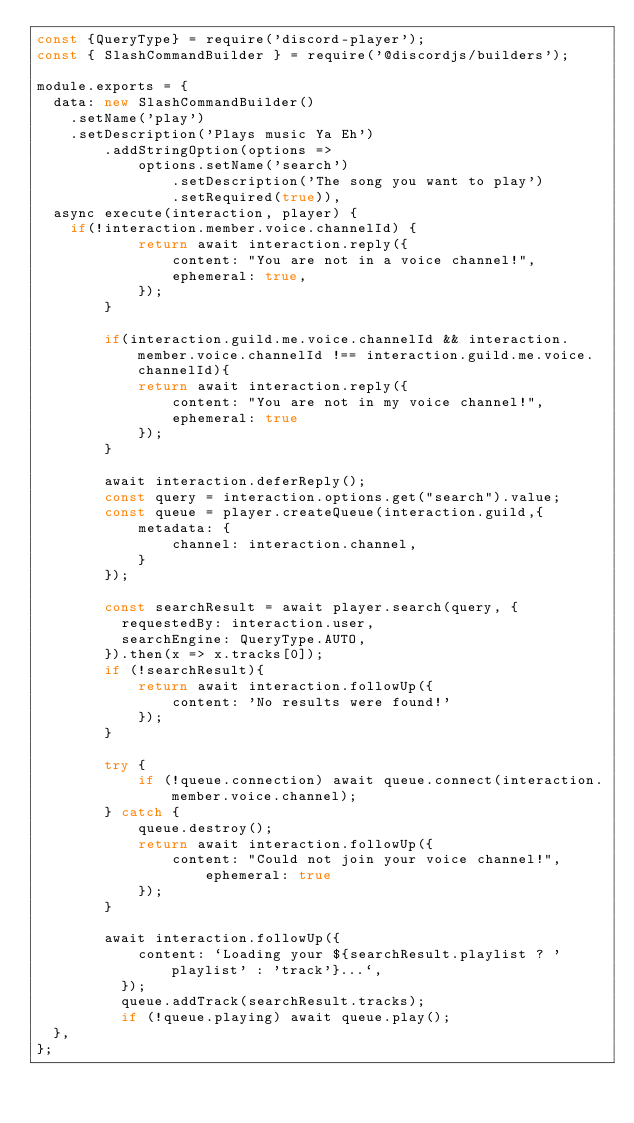<code> <loc_0><loc_0><loc_500><loc_500><_JavaScript_>const {QueryType} = require('discord-player');
const { SlashCommandBuilder } = require('@discordjs/builders');

module.exports = {
	data: new SlashCommandBuilder()
		.setName('play')
		.setDescription('Plays music Ya Eh')
        .addStringOption(options =>
            options.setName('search')
                .setDescription('The song you want to play')
                .setRequired(true)),
	async execute(interaction, player) {
		if(!interaction.member.voice.channelId) {
            return await interaction.reply({ 
                content: "You are not in a voice channel!", 
                ephemeral: true,
            });
        }

        if(interaction.guild.me.voice.channelId && interaction.member.voice.channelId !== interaction.guild.me.voice.channelId){
            return await interaction.reply({
                content: "You are not in my voice channel!",
                ephemeral: true
            });
        }
        
        await interaction.deferReply();
        const query = interaction.options.get("search").value;
        const queue = player.createQueue(interaction.guild,{
            metadata: {
                channel: interaction.channel,
            }
        });

        const searchResult = await player.search(query, {
          requestedBy: interaction.user,
          searchEngine: QueryType.AUTO,
        }).then(x => x.tracks[0]);      
        if (!searchResult){
            return await interaction.followUp({
                content: 'No results were found!'
            });
        }
        
        try {
            if (!queue.connection) await queue.connect(interaction.member.voice.channel);
        } catch {
            queue.destroy();
            return await interaction.followUp({
                content: "Could not join your voice channel!", ephemeral: true 
            });
        }

        await interaction.followUp({
            content: `Loading your ${searchResult.playlist ? 'playlist' : 'track'}...`,
          });
          queue.addTrack(searchResult.tracks);
          if (!queue.playing) await queue.play();
	},
};
</code> 